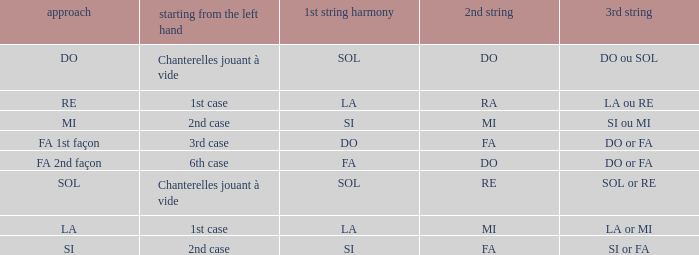What is the mode of the Depart de la main gauche of 1st case and a la or mi 3rd string? LA. 